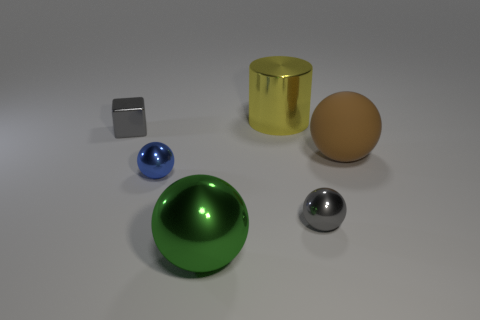There is a small sphere that is the same color as the metallic cube; what is its material?
Make the answer very short. Metal. There is another big object that is the same shape as the big green shiny thing; what material is it?
Provide a short and direct response. Rubber. There is a metal thing that is on the right side of the large yellow metallic thing; does it have the same color as the small shiny cube?
Keep it short and to the point. Yes. Is the brown matte sphere the same size as the block?
Your answer should be very brief. No. What size is the sphere that is behind the small gray metal ball and on the left side of the rubber object?
Make the answer very short. Small. There is a metallic sphere that is the same color as the cube; what size is it?
Your answer should be compact. Small. The green thing that is made of the same material as the cylinder is what size?
Provide a short and direct response. Large. How many brown things are small balls or rubber spheres?
Your answer should be very brief. 1. What is the shape of the metallic thing that is the same color as the cube?
Ensure brevity in your answer.  Sphere. Are there any other things that have the same material as the brown thing?
Offer a very short reply. No. 